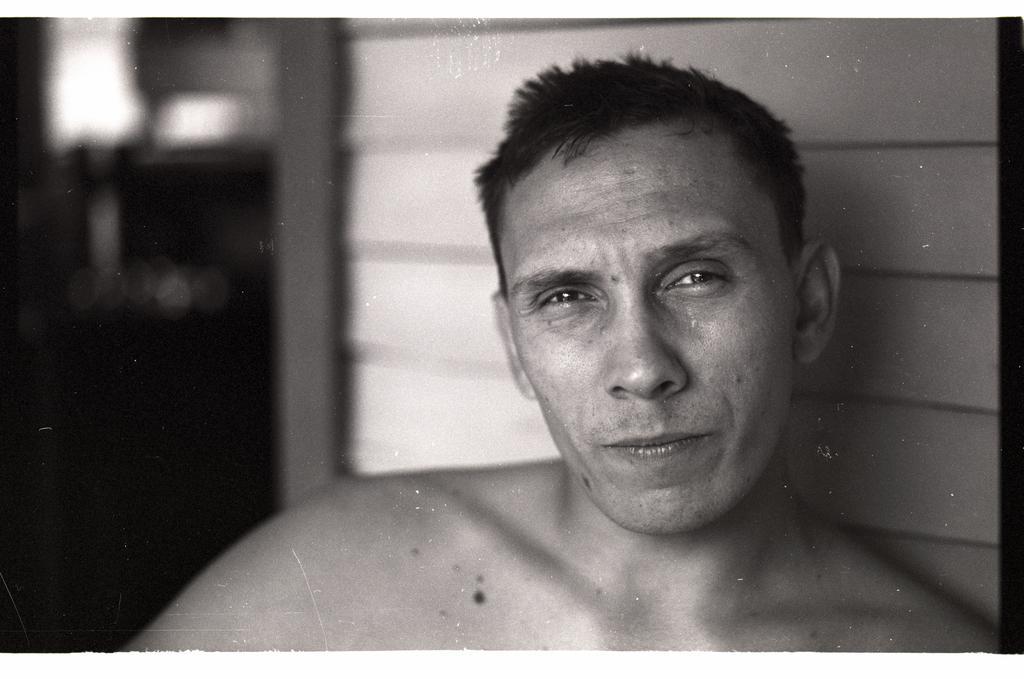Describe this image in one or two sentences. On the right side, there is a person having without a shirt and watching something. And the background is blurred. 